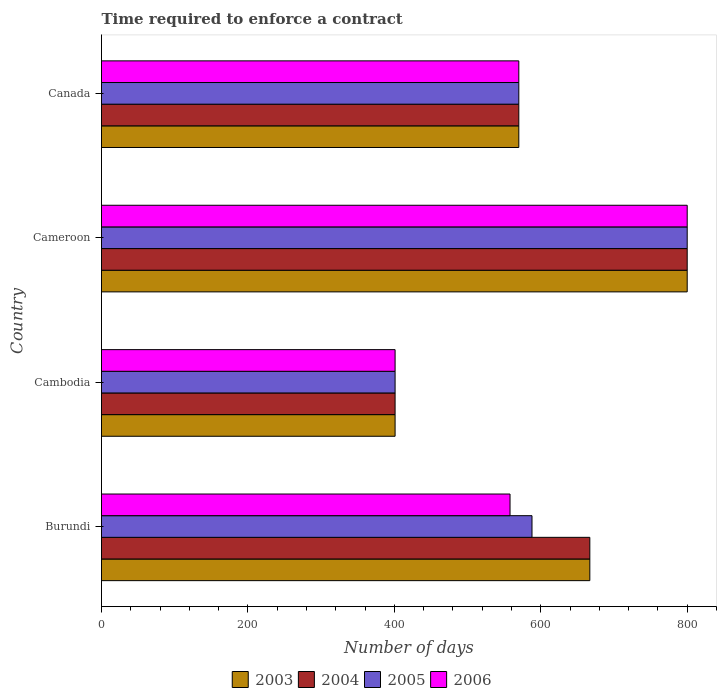Are the number of bars per tick equal to the number of legend labels?
Provide a short and direct response. Yes. Are the number of bars on each tick of the Y-axis equal?
Give a very brief answer. Yes. How many bars are there on the 4th tick from the top?
Offer a terse response. 4. What is the label of the 2nd group of bars from the top?
Provide a short and direct response. Cameroon. In how many cases, is the number of bars for a given country not equal to the number of legend labels?
Your answer should be compact. 0. What is the number of days required to enforce a contract in 2004 in Burundi?
Your answer should be very brief. 667. Across all countries, what is the maximum number of days required to enforce a contract in 2004?
Your answer should be very brief. 800. Across all countries, what is the minimum number of days required to enforce a contract in 2003?
Offer a very short reply. 401. In which country was the number of days required to enforce a contract in 2006 maximum?
Provide a succinct answer. Cameroon. In which country was the number of days required to enforce a contract in 2006 minimum?
Provide a short and direct response. Cambodia. What is the total number of days required to enforce a contract in 2005 in the graph?
Offer a very short reply. 2359. What is the difference between the number of days required to enforce a contract in 2005 in Burundi and that in Cambodia?
Offer a terse response. 187. What is the difference between the number of days required to enforce a contract in 2004 in Cambodia and the number of days required to enforce a contract in 2005 in Cameroon?
Provide a succinct answer. -399. What is the average number of days required to enforce a contract in 2003 per country?
Provide a short and direct response. 609.5. What is the difference between the number of days required to enforce a contract in 2003 and number of days required to enforce a contract in 2006 in Cambodia?
Give a very brief answer. 0. In how many countries, is the number of days required to enforce a contract in 2004 greater than 440 days?
Your answer should be compact. 3. What is the ratio of the number of days required to enforce a contract in 2005 in Burundi to that in Cameroon?
Your answer should be very brief. 0.73. Is the difference between the number of days required to enforce a contract in 2003 in Cambodia and Cameroon greater than the difference between the number of days required to enforce a contract in 2006 in Cambodia and Cameroon?
Offer a very short reply. No. What is the difference between the highest and the second highest number of days required to enforce a contract in 2006?
Your answer should be very brief. 230. What is the difference between the highest and the lowest number of days required to enforce a contract in 2006?
Your response must be concise. 399. Is it the case that in every country, the sum of the number of days required to enforce a contract in 2003 and number of days required to enforce a contract in 2004 is greater than the sum of number of days required to enforce a contract in 2005 and number of days required to enforce a contract in 2006?
Make the answer very short. No. What does the 1st bar from the top in Cambodia represents?
Your answer should be very brief. 2006. How many bars are there?
Make the answer very short. 16. How many countries are there in the graph?
Keep it short and to the point. 4. What is the difference between two consecutive major ticks on the X-axis?
Make the answer very short. 200. Does the graph contain any zero values?
Ensure brevity in your answer.  No. Where does the legend appear in the graph?
Offer a very short reply. Bottom center. How many legend labels are there?
Give a very brief answer. 4. What is the title of the graph?
Offer a terse response. Time required to enforce a contract. Does "1984" appear as one of the legend labels in the graph?
Provide a short and direct response. No. What is the label or title of the X-axis?
Make the answer very short. Number of days. What is the label or title of the Y-axis?
Make the answer very short. Country. What is the Number of days of 2003 in Burundi?
Provide a succinct answer. 667. What is the Number of days in 2004 in Burundi?
Provide a short and direct response. 667. What is the Number of days in 2005 in Burundi?
Provide a succinct answer. 588. What is the Number of days in 2006 in Burundi?
Offer a terse response. 558. What is the Number of days in 2003 in Cambodia?
Your answer should be very brief. 401. What is the Number of days of 2004 in Cambodia?
Offer a very short reply. 401. What is the Number of days in 2005 in Cambodia?
Provide a succinct answer. 401. What is the Number of days in 2006 in Cambodia?
Offer a terse response. 401. What is the Number of days in 2003 in Cameroon?
Give a very brief answer. 800. What is the Number of days in 2004 in Cameroon?
Offer a very short reply. 800. What is the Number of days in 2005 in Cameroon?
Your answer should be very brief. 800. What is the Number of days of 2006 in Cameroon?
Ensure brevity in your answer.  800. What is the Number of days in 2003 in Canada?
Your response must be concise. 570. What is the Number of days of 2004 in Canada?
Your answer should be very brief. 570. What is the Number of days in 2005 in Canada?
Make the answer very short. 570. What is the Number of days in 2006 in Canada?
Make the answer very short. 570. Across all countries, what is the maximum Number of days in 2003?
Your answer should be compact. 800. Across all countries, what is the maximum Number of days of 2004?
Your response must be concise. 800. Across all countries, what is the maximum Number of days of 2005?
Keep it short and to the point. 800. Across all countries, what is the maximum Number of days in 2006?
Keep it short and to the point. 800. Across all countries, what is the minimum Number of days of 2003?
Your response must be concise. 401. Across all countries, what is the minimum Number of days in 2004?
Your answer should be very brief. 401. Across all countries, what is the minimum Number of days in 2005?
Your answer should be compact. 401. Across all countries, what is the minimum Number of days of 2006?
Provide a succinct answer. 401. What is the total Number of days of 2003 in the graph?
Ensure brevity in your answer.  2438. What is the total Number of days in 2004 in the graph?
Give a very brief answer. 2438. What is the total Number of days in 2005 in the graph?
Ensure brevity in your answer.  2359. What is the total Number of days in 2006 in the graph?
Offer a terse response. 2329. What is the difference between the Number of days in 2003 in Burundi and that in Cambodia?
Give a very brief answer. 266. What is the difference between the Number of days of 2004 in Burundi and that in Cambodia?
Your response must be concise. 266. What is the difference between the Number of days in 2005 in Burundi and that in Cambodia?
Provide a short and direct response. 187. What is the difference between the Number of days in 2006 in Burundi and that in Cambodia?
Provide a short and direct response. 157. What is the difference between the Number of days in 2003 in Burundi and that in Cameroon?
Offer a very short reply. -133. What is the difference between the Number of days of 2004 in Burundi and that in Cameroon?
Provide a short and direct response. -133. What is the difference between the Number of days of 2005 in Burundi and that in Cameroon?
Make the answer very short. -212. What is the difference between the Number of days of 2006 in Burundi and that in Cameroon?
Provide a short and direct response. -242. What is the difference between the Number of days of 2003 in Burundi and that in Canada?
Make the answer very short. 97. What is the difference between the Number of days of 2004 in Burundi and that in Canada?
Your answer should be very brief. 97. What is the difference between the Number of days in 2005 in Burundi and that in Canada?
Give a very brief answer. 18. What is the difference between the Number of days in 2006 in Burundi and that in Canada?
Keep it short and to the point. -12. What is the difference between the Number of days in 2003 in Cambodia and that in Cameroon?
Your answer should be compact. -399. What is the difference between the Number of days in 2004 in Cambodia and that in Cameroon?
Provide a short and direct response. -399. What is the difference between the Number of days of 2005 in Cambodia and that in Cameroon?
Provide a short and direct response. -399. What is the difference between the Number of days in 2006 in Cambodia and that in Cameroon?
Your response must be concise. -399. What is the difference between the Number of days of 2003 in Cambodia and that in Canada?
Ensure brevity in your answer.  -169. What is the difference between the Number of days of 2004 in Cambodia and that in Canada?
Keep it short and to the point. -169. What is the difference between the Number of days of 2005 in Cambodia and that in Canada?
Your answer should be very brief. -169. What is the difference between the Number of days in 2006 in Cambodia and that in Canada?
Your answer should be very brief. -169. What is the difference between the Number of days in 2003 in Cameroon and that in Canada?
Provide a succinct answer. 230. What is the difference between the Number of days of 2004 in Cameroon and that in Canada?
Keep it short and to the point. 230. What is the difference between the Number of days of 2005 in Cameroon and that in Canada?
Provide a succinct answer. 230. What is the difference between the Number of days in 2006 in Cameroon and that in Canada?
Your response must be concise. 230. What is the difference between the Number of days in 2003 in Burundi and the Number of days in 2004 in Cambodia?
Make the answer very short. 266. What is the difference between the Number of days of 2003 in Burundi and the Number of days of 2005 in Cambodia?
Your answer should be very brief. 266. What is the difference between the Number of days in 2003 in Burundi and the Number of days in 2006 in Cambodia?
Keep it short and to the point. 266. What is the difference between the Number of days in 2004 in Burundi and the Number of days in 2005 in Cambodia?
Your answer should be very brief. 266. What is the difference between the Number of days in 2004 in Burundi and the Number of days in 2006 in Cambodia?
Offer a terse response. 266. What is the difference between the Number of days in 2005 in Burundi and the Number of days in 2006 in Cambodia?
Provide a succinct answer. 187. What is the difference between the Number of days in 2003 in Burundi and the Number of days in 2004 in Cameroon?
Keep it short and to the point. -133. What is the difference between the Number of days in 2003 in Burundi and the Number of days in 2005 in Cameroon?
Offer a very short reply. -133. What is the difference between the Number of days of 2003 in Burundi and the Number of days of 2006 in Cameroon?
Provide a succinct answer. -133. What is the difference between the Number of days of 2004 in Burundi and the Number of days of 2005 in Cameroon?
Make the answer very short. -133. What is the difference between the Number of days of 2004 in Burundi and the Number of days of 2006 in Cameroon?
Provide a short and direct response. -133. What is the difference between the Number of days in 2005 in Burundi and the Number of days in 2006 in Cameroon?
Your answer should be compact. -212. What is the difference between the Number of days of 2003 in Burundi and the Number of days of 2004 in Canada?
Your answer should be very brief. 97. What is the difference between the Number of days in 2003 in Burundi and the Number of days in 2005 in Canada?
Provide a short and direct response. 97. What is the difference between the Number of days of 2003 in Burundi and the Number of days of 2006 in Canada?
Provide a succinct answer. 97. What is the difference between the Number of days of 2004 in Burundi and the Number of days of 2005 in Canada?
Give a very brief answer. 97. What is the difference between the Number of days of 2004 in Burundi and the Number of days of 2006 in Canada?
Your answer should be compact. 97. What is the difference between the Number of days of 2005 in Burundi and the Number of days of 2006 in Canada?
Provide a succinct answer. 18. What is the difference between the Number of days in 2003 in Cambodia and the Number of days in 2004 in Cameroon?
Ensure brevity in your answer.  -399. What is the difference between the Number of days in 2003 in Cambodia and the Number of days in 2005 in Cameroon?
Your answer should be very brief. -399. What is the difference between the Number of days of 2003 in Cambodia and the Number of days of 2006 in Cameroon?
Your answer should be very brief. -399. What is the difference between the Number of days of 2004 in Cambodia and the Number of days of 2005 in Cameroon?
Provide a succinct answer. -399. What is the difference between the Number of days in 2004 in Cambodia and the Number of days in 2006 in Cameroon?
Ensure brevity in your answer.  -399. What is the difference between the Number of days in 2005 in Cambodia and the Number of days in 2006 in Cameroon?
Provide a succinct answer. -399. What is the difference between the Number of days of 2003 in Cambodia and the Number of days of 2004 in Canada?
Your response must be concise. -169. What is the difference between the Number of days in 2003 in Cambodia and the Number of days in 2005 in Canada?
Offer a very short reply. -169. What is the difference between the Number of days of 2003 in Cambodia and the Number of days of 2006 in Canada?
Provide a succinct answer. -169. What is the difference between the Number of days of 2004 in Cambodia and the Number of days of 2005 in Canada?
Your answer should be very brief. -169. What is the difference between the Number of days in 2004 in Cambodia and the Number of days in 2006 in Canada?
Provide a short and direct response. -169. What is the difference between the Number of days in 2005 in Cambodia and the Number of days in 2006 in Canada?
Ensure brevity in your answer.  -169. What is the difference between the Number of days of 2003 in Cameroon and the Number of days of 2004 in Canada?
Offer a terse response. 230. What is the difference between the Number of days of 2003 in Cameroon and the Number of days of 2005 in Canada?
Your answer should be compact. 230. What is the difference between the Number of days of 2003 in Cameroon and the Number of days of 2006 in Canada?
Ensure brevity in your answer.  230. What is the difference between the Number of days of 2004 in Cameroon and the Number of days of 2005 in Canada?
Your answer should be compact. 230. What is the difference between the Number of days in 2004 in Cameroon and the Number of days in 2006 in Canada?
Your response must be concise. 230. What is the difference between the Number of days of 2005 in Cameroon and the Number of days of 2006 in Canada?
Ensure brevity in your answer.  230. What is the average Number of days in 2003 per country?
Your response must be concise. 609.5. What is the average Number of days of 2004 per country?
Your response must be concise. 609.5. What is the average Number of days of 2005 per country?
Your answer should be compact. 589.75. What is the average Number of days of 2006 per country?
Make the answer very short. 582.25. What is the difference between the Number of days of 2003 and Number of days of 2004 in Burundi?
Make the answer very short. 0. What is the difference between the Number of days of 2003 and Number of days of 2005 in Burundi?
Provide a short and direct response. 79. What is the difference between the Number of days in 2003 and Number of days in 2006 in Burundi?
Your answer should be compact. 109. What is the difference between the Number of days in 2004 and Number of days in 2005 in Burundi?
Make the answer very short. 79. What is the difference between the Number of days in 2004 and Number of days in 2006 in Burundi?
Offer a very short reply. 109. What is the difference between the Number of days of 2005 and Number of days of 2006 in Burundi?
Your response must be concise. 30. What is the difference between the Number of days in 2004 and Number of days in 2005 in Cambodia?
Your answer should be very brief. 0. What is the difference between the Number of days in 2004 and Number of days in 2006 in Cambodia?
Make the answer very short. 0. What is the difference between the Number of days in 2003 and Number of days in 2004 in Cameroon?
Make the answer very short. 0. What is the difference between the Number of days in 2003 and Number of days in 2005 in Cameroon?
Provide a succinct answer. 0. What is the difference between the Number of days of 2004 and Number of days of 2005 in Cameroon?
Ensure brevity in your answer.  0. What is the difference between the Number of days of 2004 and Number of days of 2005 in Canada?
Offer a terse response. 0. What is the difference between the Number of days of 2004 and Number of days of 2006 in Canada?
Give a very brief answer. 0. What is the difference between the Number of days of 2005 and Number of days of 2006 in Canada?
Your answer should be compact. 0. What is the ratio of the Number of days in 2003 in Burundi to that in Cambodia?
Keep it short and to the point. 1.66. What is the ratio of the Number of days in 2004 in Burundi to that in Cambodia?
Make the answer very short. 1.66. What is the ratio of the Number of days in 2005 in Burundi to that in Cambodia?
Keep it short and to the point. 1.47. What is the ratio of the Number of days in 2006 in Burundi to that in Cambodia?
Ensure brevity in your answer.  1.39. What is the ratio of the Number of days of 2003 in Burundi to that in Cameroon?
Provide a succinct answer. 0.83. What is the ratio of the Number of days in 2004 in Burundi to that in Cameroon?
Provide a short and direct response. 0.83. What is the ratio of the Number of days of 2005 in Burundi to that in Cameroon?
Provide a short and direct response. 0.73. What is the ratio of the Number of days in 2006 in Burundi to that in Cameroon?
Offer a very short reply. 0.7. What is the ratio of the Number of days in 2003 in Burundi to that in Canada?
Offer a terse response. 1.17. What is the ratio of the Number of days in 2004 in Burundi to that in Canada?
Provide a succinct answer. 1.17. What is the ratio of the Number of days in 2005 in Burundi to that in Canada?
Offer a very short reply. 1.03. What is the ratio of the Number of days of 2006 in Burundi to that in Canada?
Offer a terse response. 0.98. What is the ratio of the Number of days in 2003 in Cambodia to that in Cameroon?
Your answer should be very brief. 0.5. What is the ratio of the Number of days of 2004 in Cambodia to that in Cameroon?
Your answer should be compact. 0.5. What is the ratio of the Number of days of 2005 in Cambodia to that in Cameroon?
Your response must be concise. 0.5. What is the ratio of the Number of days in 2006 in Cambodia to that in Cameroon?
Offer a terse response. 0.5. What is the ratio of the Number of days of 2003 in Cambodia to that in Canada?
Provide a short and direct response. 0.7. What is the ratio of the Number of days in 2004 in Cambodia to that in Canada?
Offer a very short reply. 0.7. What is the ratio of the Number of days of 2005 in Cambodia to that in Canada?
Your answer should be compact. 0.7. What is the ratio of the Number of days in 2006 in Cambodia to that in Canada?
Your answer should be very brief. 0.7. What is the ratio of the Number of days in 2003 in Cameroon to that in Canada?
Make the answer very short. 1.4. What is the ratio of the Number of days of 2004 in Cameroon to that in Canada?
Give a very brief answer. 1.4. What is the ratio of the Number of days in 2005 in Cameroon to that in Canada?
Give a very brief answer. 1.4. What is the ratio of the Number of days of 2006 in Cameroon to that in Canada?
Your answer should be very brief. 1.4. What is the difference between the highest and the second highest Number of days of 2003?
Provide a succinct answer. 133. What is the difference between the highest and the second highest Number of days of 2004?
Your answer should be compact. 133. What is the difference between the highest and the second highest Number of days in 2005?
Give a very brief answer. 212. What is the difference between the highest and the second highest Number of days of 2006?
Provide a succinct answer. 230. What is the difference between the highest and the lowest Number of days of 2003?
Give a very brief answer. 399. What is the difference between the highest and the lowest Number of days in 2004?
Give a very brief answer. 399. What is the difference between the highest and the lowest Number of days in 2005?
Your response must be concise. 399. What is the difference between the highest and the lowest Number of days in 2006?
Give a very brief answer. 399. 